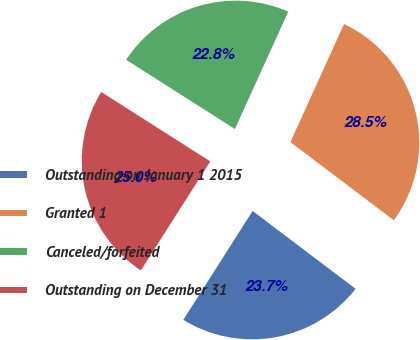Convert chart. <chart><loc_0><loc_0><loc_500><loc_500><pie_chart><fcel>Outstanding on January 1 2015<fcel>Granted 1<fcel>Canceled/forfeited<fcel>Outstanding on December 31<nl><fcel>23.72%<fcel>28.52%<fcel>22.76%<fcel>25.0%<nl></chart> 